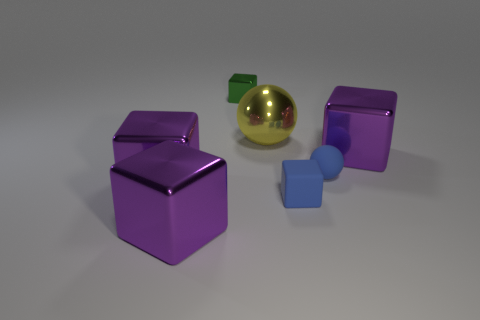Subtract all purple blocks. How many were subtracted if there are1purple blocks left? 2 Subtract all purple blocks. How many blocks are left? 2 Subtract all purple blocks. How many blocks are left? 2 Subtract all brown spheres. Subtract all brown cylinders. How many spheres are left? 2 Add 3 big yellow shiny objects. How many big yellow shiny objects exist? 4 Add 2 rubber objects. How many objects exist? 9 Subtract 0 cyan balls. How many objects are left? 7 Subtract all blocks. How many objects are left? 2 Subtract 2 spheres. How many spheres are left? 0 Subtract all purple cubes. How many yellow balls are left? 1 